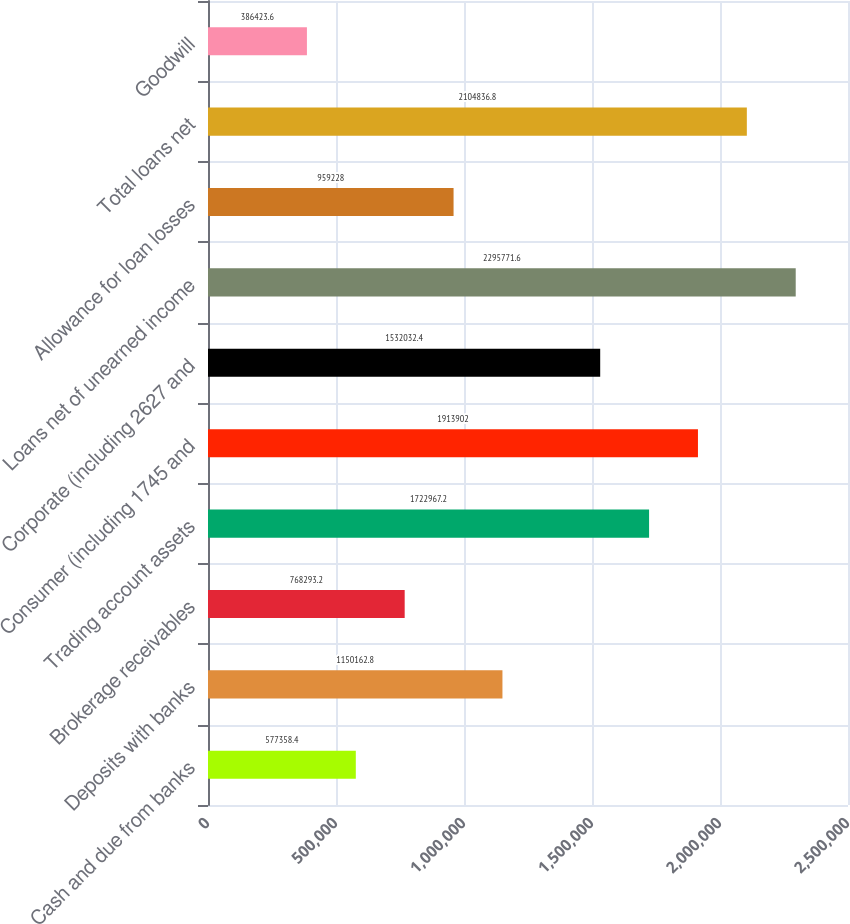Convert chart to OTSL. <chart><loc_0><loc_0><loc_500><loc_500><bar_chart><fcel>Cash and due from banks<fcel>Deposits with banks<fcel>Brokerage receivables<fcel>Trading account assets<fcel>Consumer (including 1745 and<fcel>Corporate (including 2627 and<fcel>Loans net of unearned income<fcel>Allowance for loan losses<fcel>Total loans net<fcel>Goodwill<nl><fcel>577358<fcel>1.15016e+06<fcel>768293<fcel>1.72297e+06<fcel>1.9139e+06<fcel>1.53203e+06<fcel>2.29577e+06<fcel>959228<fcel>2.10484e+06<fcel>386424<nl></chart> 